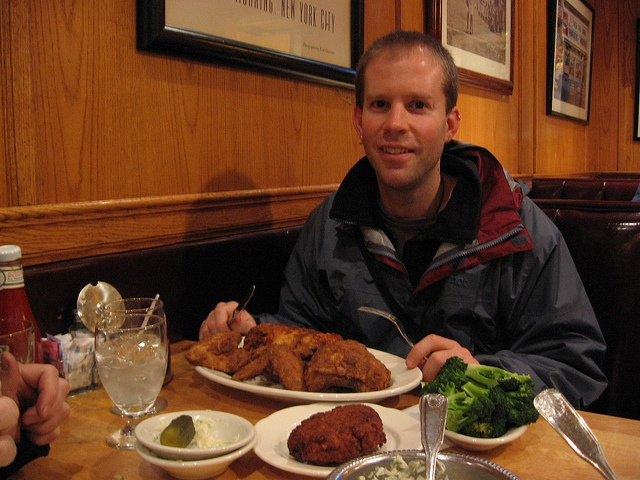Describe the objects in this image and their specific colors. I can see people in maroon, black, brown, and gray tones, dining table in maroon, brown, black, and tan tones, wine glass in maroon, gray, olive, and tan tones, broccoli in maroon, black, darkgreen, and olive tones, and people in maroon, brown, salmon, and black tones in this image. 